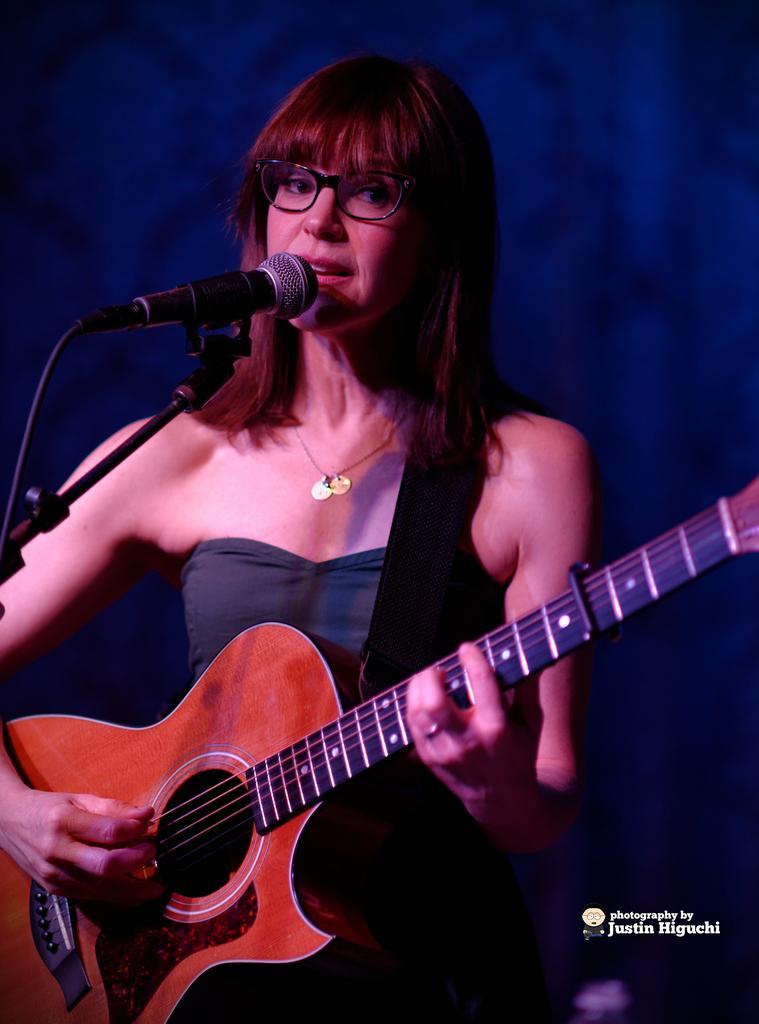Can you describe this image briefly? A woman is standing and holding a guitar and also she is singing in the microphone. 